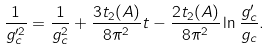<formula> <loc_0><loc_0><loc_500><loc_500>\frac { 1 } { g ^ { \prime 2 } _ { c } } = \frac { 1 } { g _ { c } ^ { 2 } } + \frac { 3 t _ { 2 } ( A ) } { 8 \pi ^ { 2 } } t - \frac { 2 t _ { 2 } ( A ) } { 8 \pi ^ { 2 } } \ln \frac { g _ { c } ^ { \prime } } { g _ { c } } .</formula> 